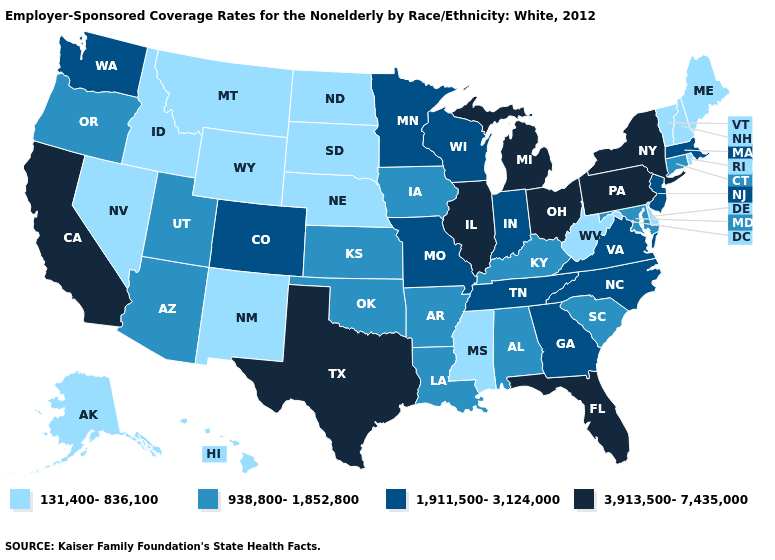Name the states that have a value in the range 131,400-836,100?
Keep it brief. Alaska, Delaware, Hawaii, Idaho, Maine, Mississippi, Montana, Nebraska, Nevada, New Hampshire, New Mexico, North Dakota, Rhode Island, South Dakota, Vermont, West Virginia, Wyoming. What is the value of Montana?
Concise answer only. 131,400-836,100. What is the value of Oregon?
Keep it brief. 938,800-1,852,800. Which states have the lowest value in the South?
Be succinct. Delaware, Mississippi, West Virginia. Does New Mexico have the lowest value in the USA?
Be succinct. Yes. Does the map have missing data?
Keep it brief. No. Does Illinois have the lowest value in the USA?
Keep it brief. No. Name the states that have a value in the range 3,913,500-7,435,000?
Concise answer only. California, Florida, Illinois, Michigan, New York, Ohio, Pennsylvania, Texas. What is the value of Mississippi?
Give a very brief answer. 131,400-836,100. What is the lowest value in states that border Arkansas?
Keep it brief. 131,400-836,100. What is the value of Pennsylvania?
Keep it brief. 3,913,500-7,435,000. Which states hav the highest value in the Northeast?
Answer briefly. New York, Pennsylvania. What is the value of Arizona?
Keep it brief. 938,800-1,852,800. Name the states that have a value in the range 938,800-1,852,800?
Answer briefly. Alabama, Arizona, Arkansas, Connecticut, Iowa, Kansas, Kentucky, Louisiana, Maryland, Oklahoma, Oregon, South Carolina, Utah. What is the lowest value in the USA?
Concise answer only. 131,400-836,100. 